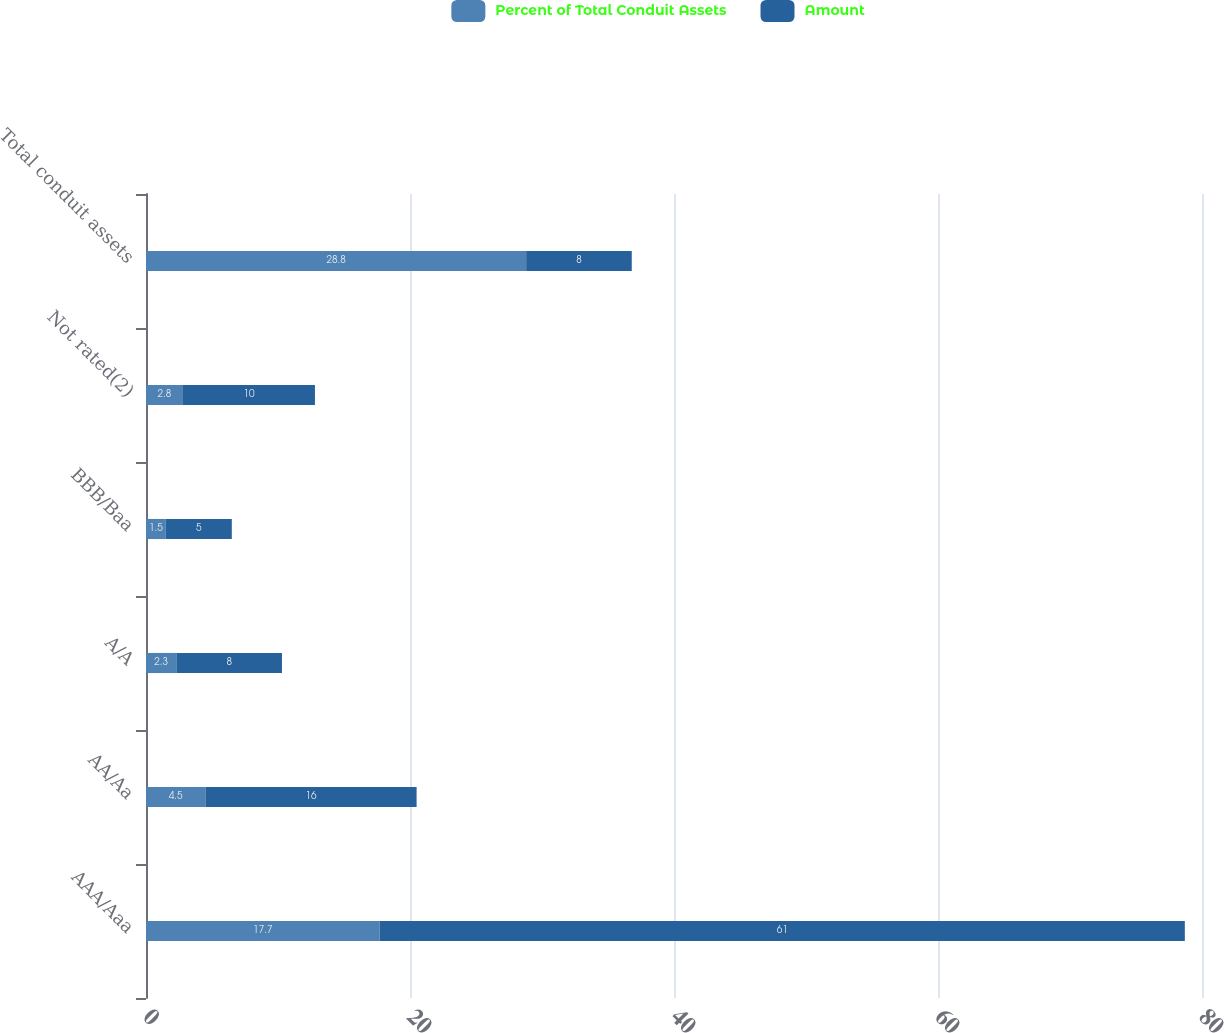Convert chart to OTSL. <chart><loc_0><loc_0><loc_500><loc_500><stacked_bar_chart><ecel><fcel>AAA/Aaa<fcel>AA/Aa<fcel>A/A<fcel>BBB/Baa<fcel>Not rated(2)<fcel>Total conduit assets<nl><fcel>Percent of Total Conduit Assets<fcel>17.7<fcel>4.5<fcel>2.3<fcel>1.5<fcel>2.8<fcel>28.8<nl><fcel>Amount<fcel>61<fcel>16<fcel>8<fcel>5<fcel>10<fcel>8<nl></chart> 